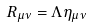Convert formula to latex. <formula><loc_0><loc_0><loc_500><loc_500>R _ { \mu \nu } = \Lambda \eta _ { \mu \nu }</formula> 